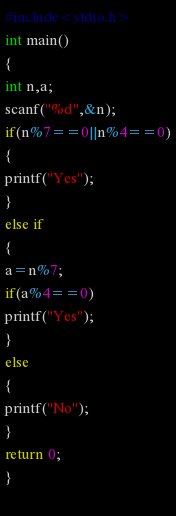Convert code to text. <code><loc_0><loc_0><loc_500><loc_500><_C_>#include<stdio.h>
int main()
{
int n,a;
scanf("%d",&n);
if(n%7==0||n%4==0)
{
printf("Yes");
}
else if
{
a=n%7;
if(a%4==0)
printf("Yes");
}
else
{
printf("No");
}
return 0;
}
 </code> 